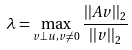Convert formula to latex. <formula><loc_0><loc_0><loc_500><loc_500>\lambda = \max _ { v \perp u , v \ne 0 } \frac { | | A v | | _ { 2 } } { | | v | | _ { 2 } }</formula> 